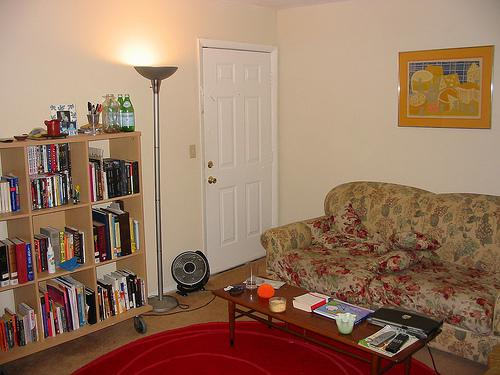Question: where do you see cheese?
Choices:
A. Buger.
B. Painting.
C. Child.
D. Floor.
Answer with the letter. Answer: B Question: where is the fan?
Choices:
A. Ceiling.
B. Outside.
C. Living room.
D. On the floor.
Answer with the letter. Answer: D Question: what type of room is this?
Choices:
A. Kitchen.
B. Bathroom.
C. Bedroom.
D. Living room.
Answer with the letter. Answer: D Question: why is the light on?
Choices:
A. Night.
B. Dark.
C. No windows.
D. To see.
Answer with the letter. Answer: C Question: what is the bookshelf on?
Choices:
A. Shelf.
B. Bricks.
C. Wheels.
D. Wood.
Answer with the letter. Answer: C 